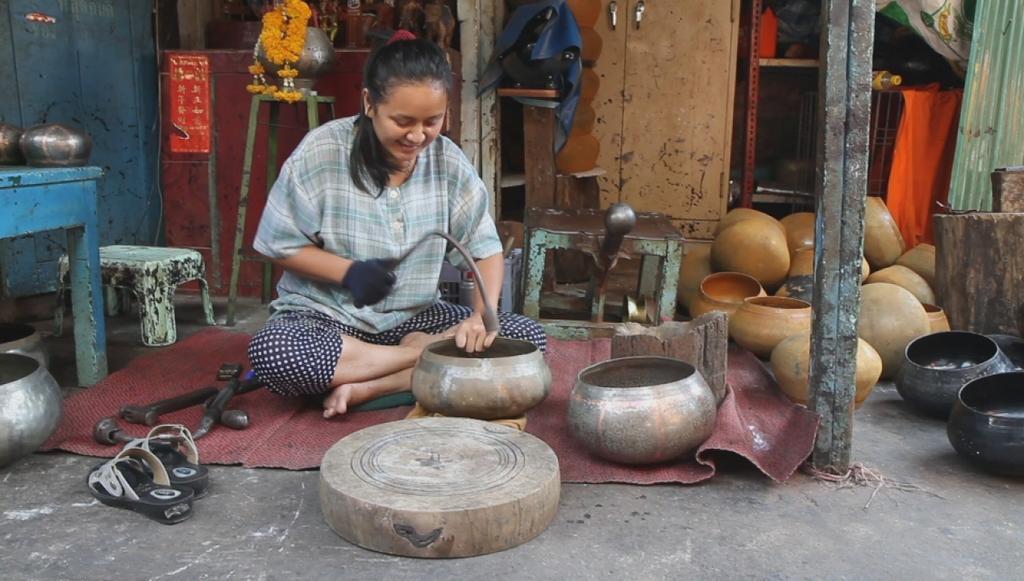Could you give a brief overview of what you see in this image? In this picture I can see a woman is sitting on the mat. The woman is holding an object in the hand. The woman is smiling. In the background I can see cupboard, flowers, table, stool and some other objects on the ground. Here I can see a wooden object. 